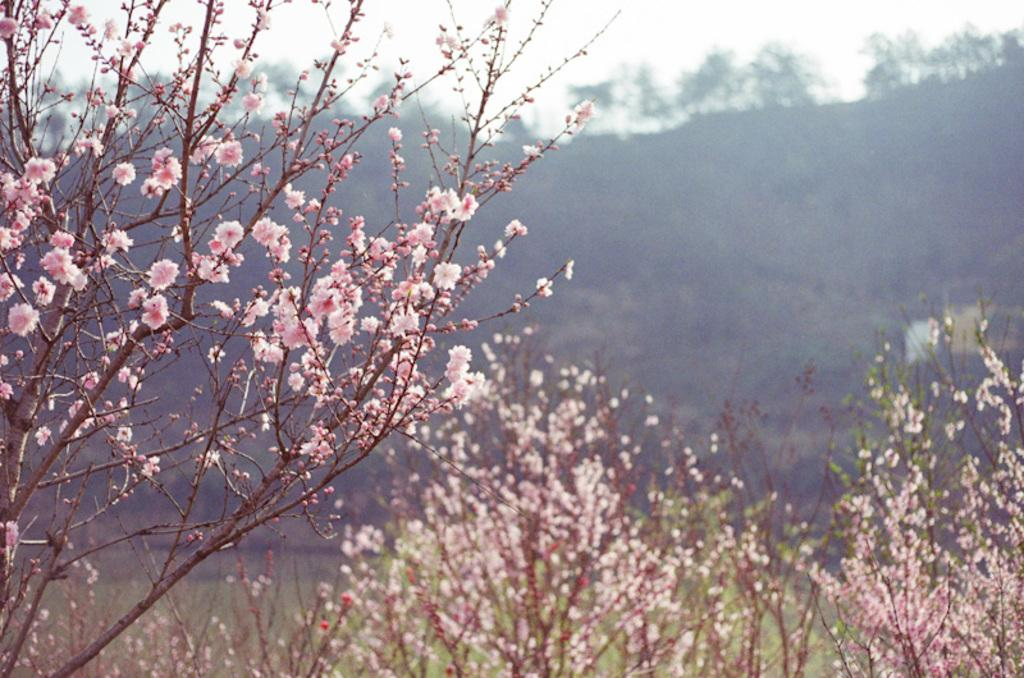What type of flora is present in the image? There are flowers in the image. What color are the flowers? The flowers are pink in color. What can be seen in the background of the image? There are trees and the sky visible in the background of the image. What type of texture can be seen on the cakes in the image? There are no cakes present in the image; it features flowers and a background with trees and the sky. 